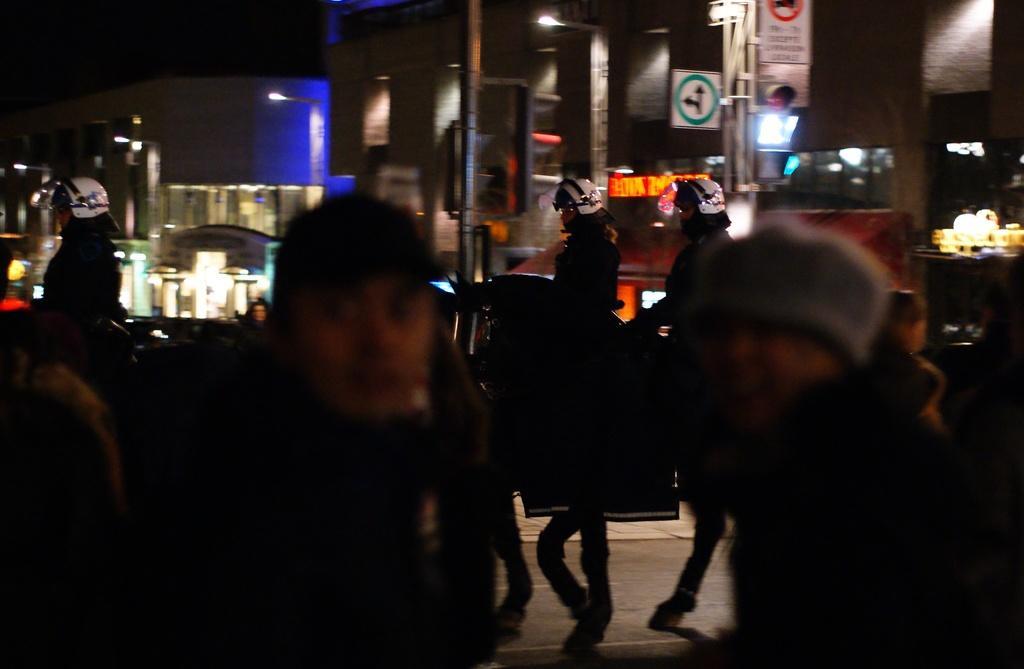Can you describe this image briefly? In this image in the foreground there are some people, and in the background there are some people who are sitting on horses. And there are some buildings, poles, boards, lights and some objects. At the bottom there is a walkway. 